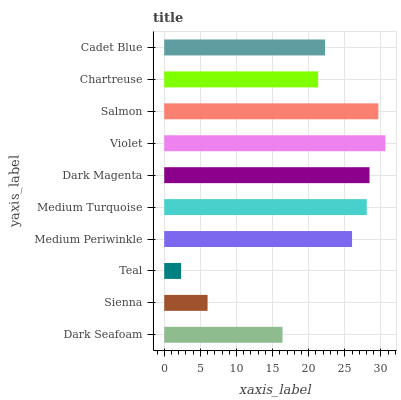Is Teal the minimum?
Answer yes or no. Yes. Is Violet the maximum?
Answer yes or no. Yes. Is Sienna the minimum?
Answer yes or no. No. Is Sienna the maximum?
Answer yes or no. No. Is Dark Seafoam greater than Sienna?
Answer yes or no. Yes. Is Sienna less than Dark Seafoam?
Answer yes or no. Yes. Is Sienna greater than Dark Seafoam?
Answer yes or no. No. Is Dark Seafoam less than Sienna?
Answer yes or no. No. Is Medium Periwinkle the high median?
Answer yes or no. Yes. Is Cadet Blue the low median?
Answer yes or no. Yes. Is Dark Seafoam the high median?
Answer yes or no. No. Is Dark Seafoam the low median?
Answer yes or no. No. 